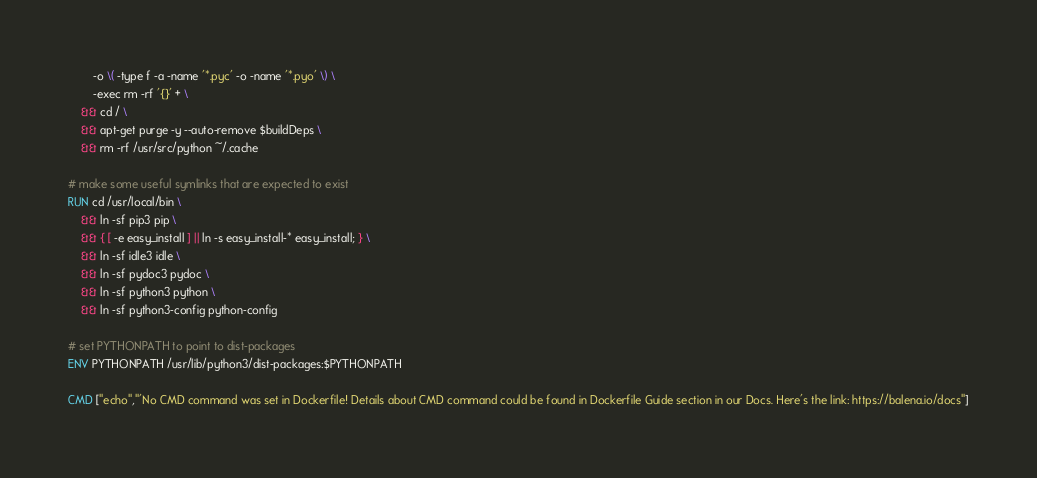<code> <loc_0><loc_0><loc_500><loc_500><_Dockerfile_>		-o \( -type f -a -name '*.pyc' -o -name '*.pyo' \) \
		-exec rm -rf '{}' + \
	&& cd / \
	&& apt-get purge -y --auto-remove $buildDeps \
	&& rm -rf /usr/src/python ~/.cache

# make some useful symlinks that are expected to exist
RUN cd /usr/local/bin \
	&& ln -sf pip3 pip \
	&& { [ -e easy_install ] || ln -s easy_install-* easy_install; } \
	&& ln -sf idle3 idle \
	&& ln -sf pydoc3 pydoc \
	&& ln -sf python3 python \
	&& ln -sf python3-config python-config

# set PYTHONPATH to point to dist-packages
ENV PYTHONPATH /usr/lib/python3/dist-packages:$PYTHONPATH

CMD ["echo","'No CMD command was set in Dockerfile! Details about CMD command could be found in Dockerfile Guide section in our Docs. Here's the link: https://balena.io/docs"]</code> 